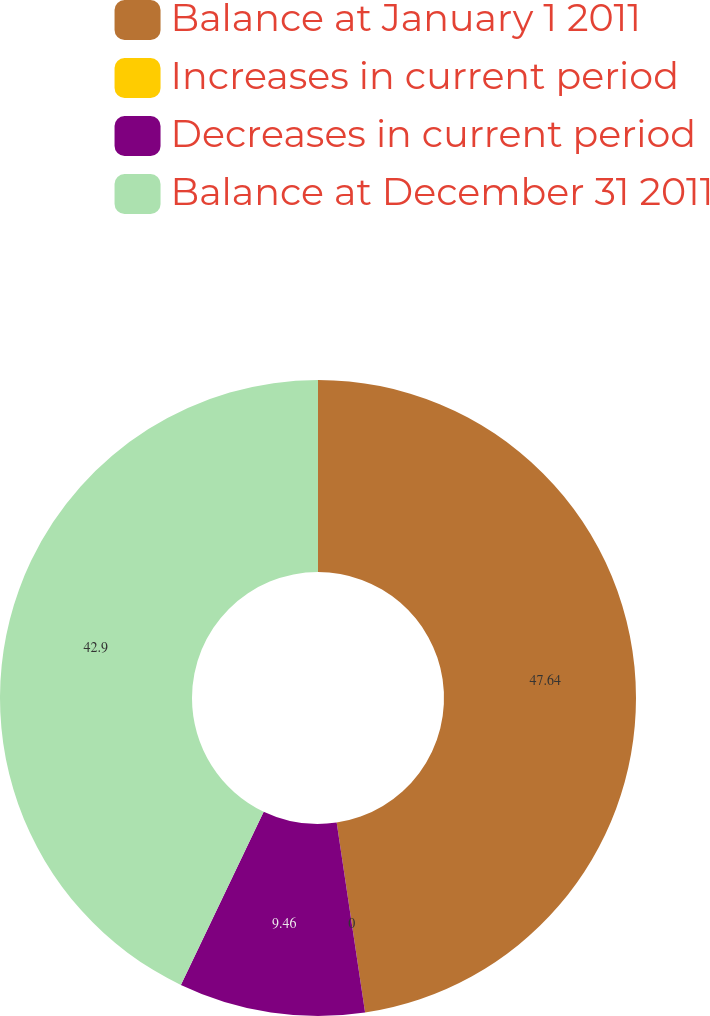Convert chart to OTSL. <chart><loc_0><loc_0><loc_500><loc_500><pie_chart><fcel>Balance at January 1 2011<fcel>Increases in current period<fcel>Decreases in current period<fcel>Balance at December 31 2011<nl><fcel>47.63%<fcel>0.0%<fcel>9.46%<fcel>42.9%<nl></chart> 